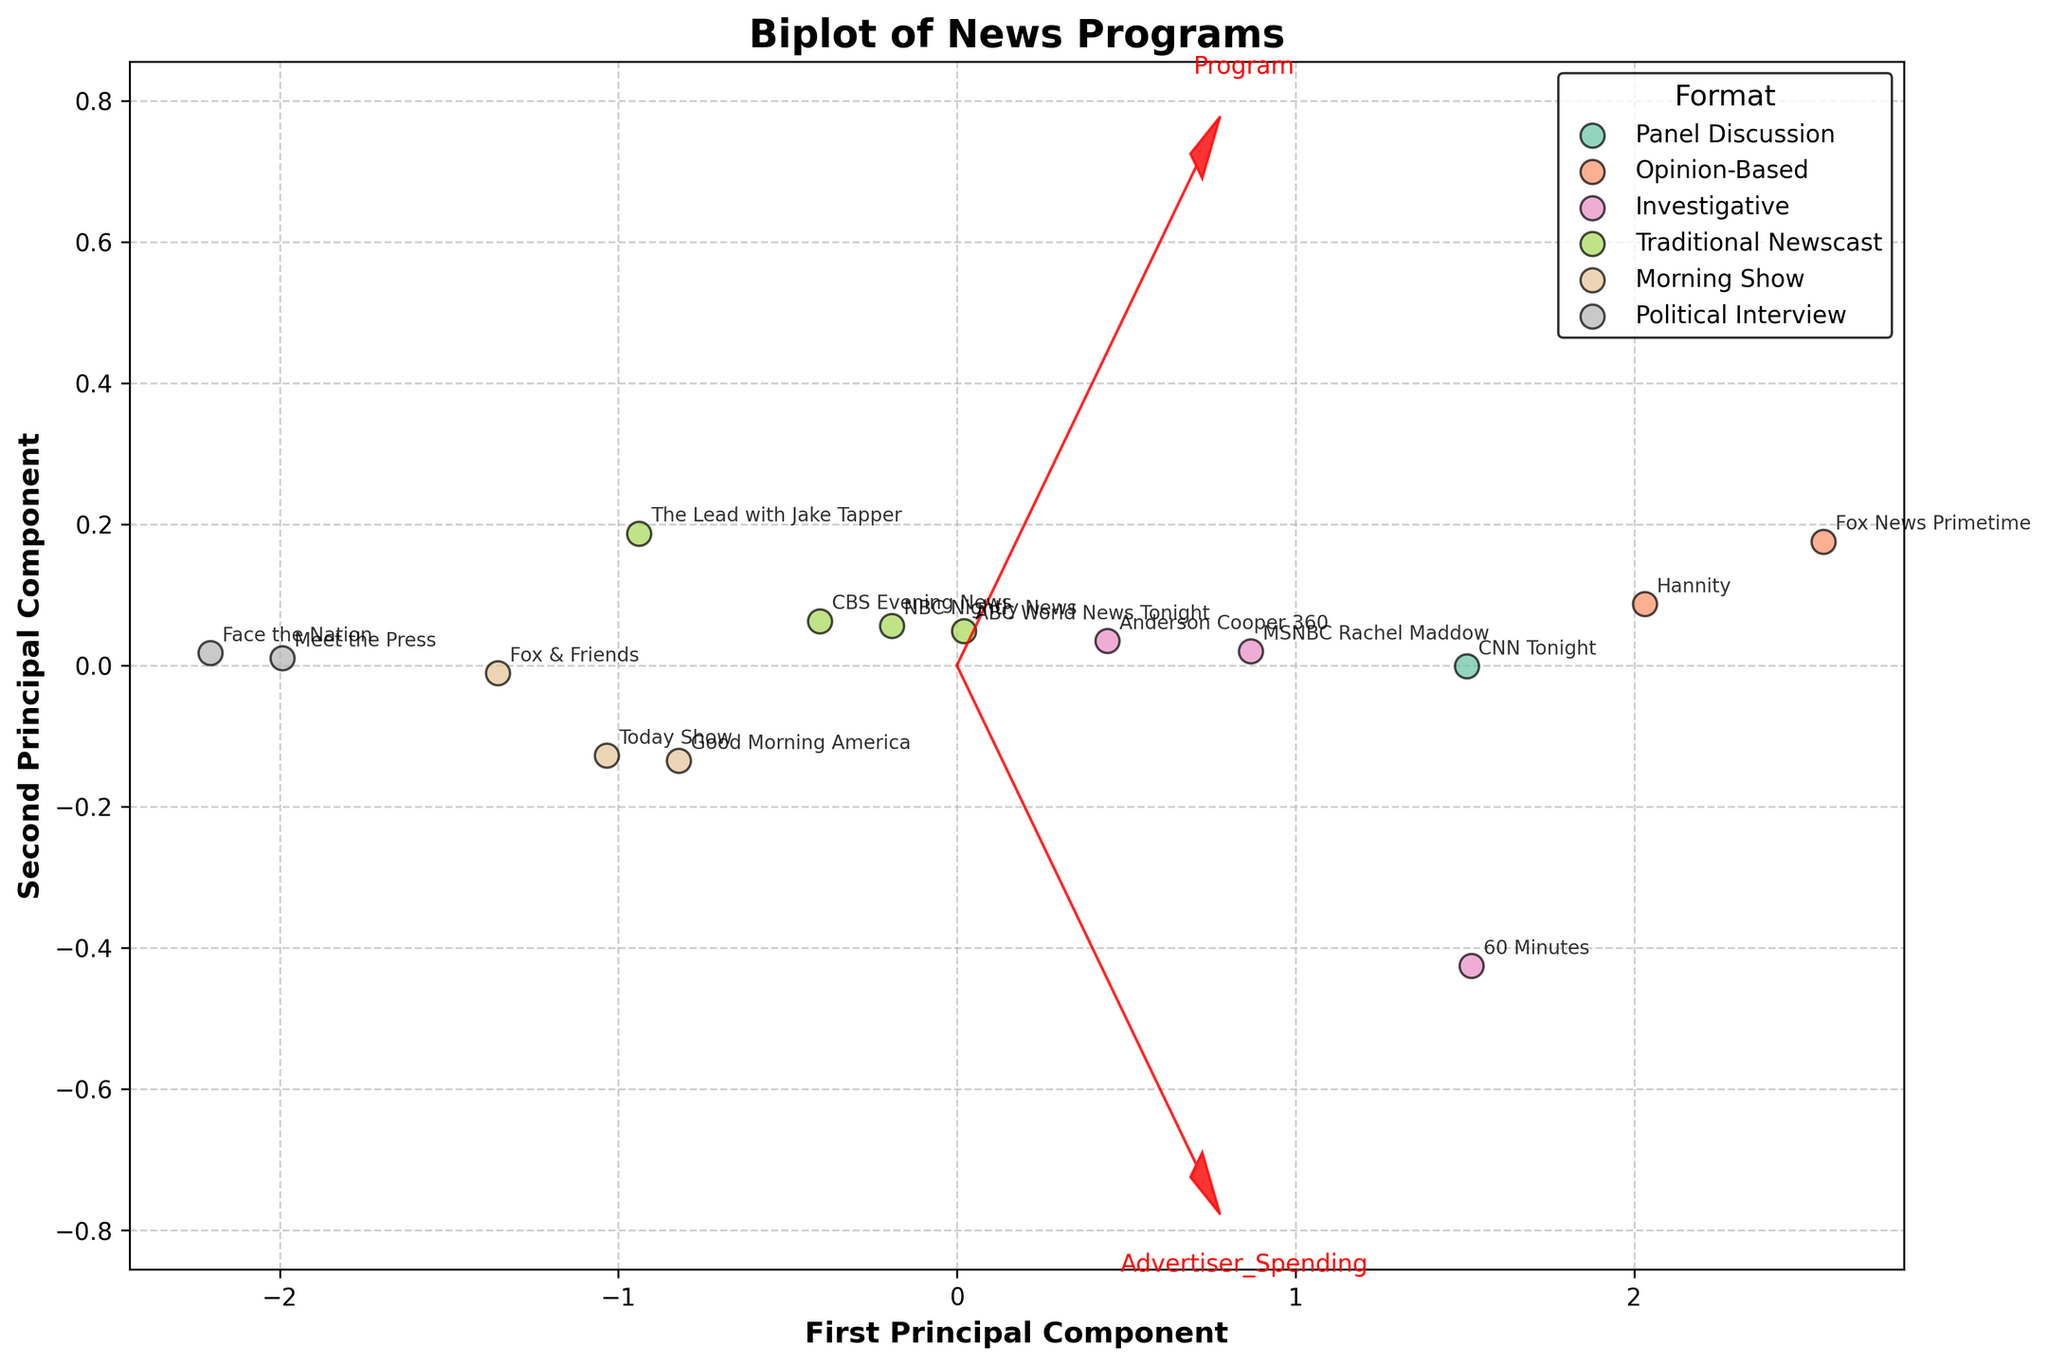How many different news program formats are represented in the biplot? The legend in the biplot shows unique categories for 'Format'. Counting these categories reveals the number of different news program formats.
Answer: Five What are the labels of the x-axis and y-axis? The labels of the axes can be directly read from the figure. The x-axis is labeled as 'First Principal Component' and the y-axis is labeled as 'Second Principal Component'.
Answer: First Principal Component, Second Principal Component Which news program has the highest advertiser spending and also appears closer to the 'Advertiser_Spending' arrow on the biplot? The direction of the 'Advertiser_Spending' arrow in the biplot indicates higher values in that direction. The point farthest along this direction and closest to the 'Advertiser_Spending' arrow corresponds to 'Fox News Primetime' with $3,800,000.
Answer: Fox News Primetime How many news programs are formatted as 'Morning Show', and where are they generally located in the biplot? Identify the 'Morning Show' format in the legend and count the points with the corresponding color. These points are generally located in one area of the plot.
Answer: Three; clustered together in the lower-left quadrant Is 'Prime Time' the only time slot with 'Opinion-Based' formats, and how many such programs are there? Refer to the legend for 'Opinion-Based' formats, and check the annotations for their corresponding 'Time Slots'.
Answer: Yes; there are two programs Which type of program format appears to have more retention, 'Traditional Newscast' or 'Political Interview'? Observing the position along the 'Viewer_Retention' arrow helps infer which formats lie closer.
Answer: Traditional Newscast What are the two vectors representing, and what does their direction indicate? The vectors in the biplot represent the original features 'Advertiser_Spending' and 'Viewer_Retention'. The direction and length indicate how each feature contributes to the principal components and the relationship with the data distribution.
Answer: Advertiser_Spending, Viewer_Retention Which program formats have data points closest to the origin of the biplot, indicating average values for both metrics? Identify the format colors and look for the points near the (0,0) in the biplot. These points indicate average values in 'Advertiser_Spending' and 'Viewer_Retention'.
Answer: Morning Show Are 'Investigative' programs generally attracting higher viewer retention compared to 'Political Interview' formats, based on their position relative to the 'Viewer_Retention' vector? Check the relative positions along the 'Viewer_Retention' arrow for points labeled 'Investigative' compared to 'Political Interview'.
Answer: Yes 